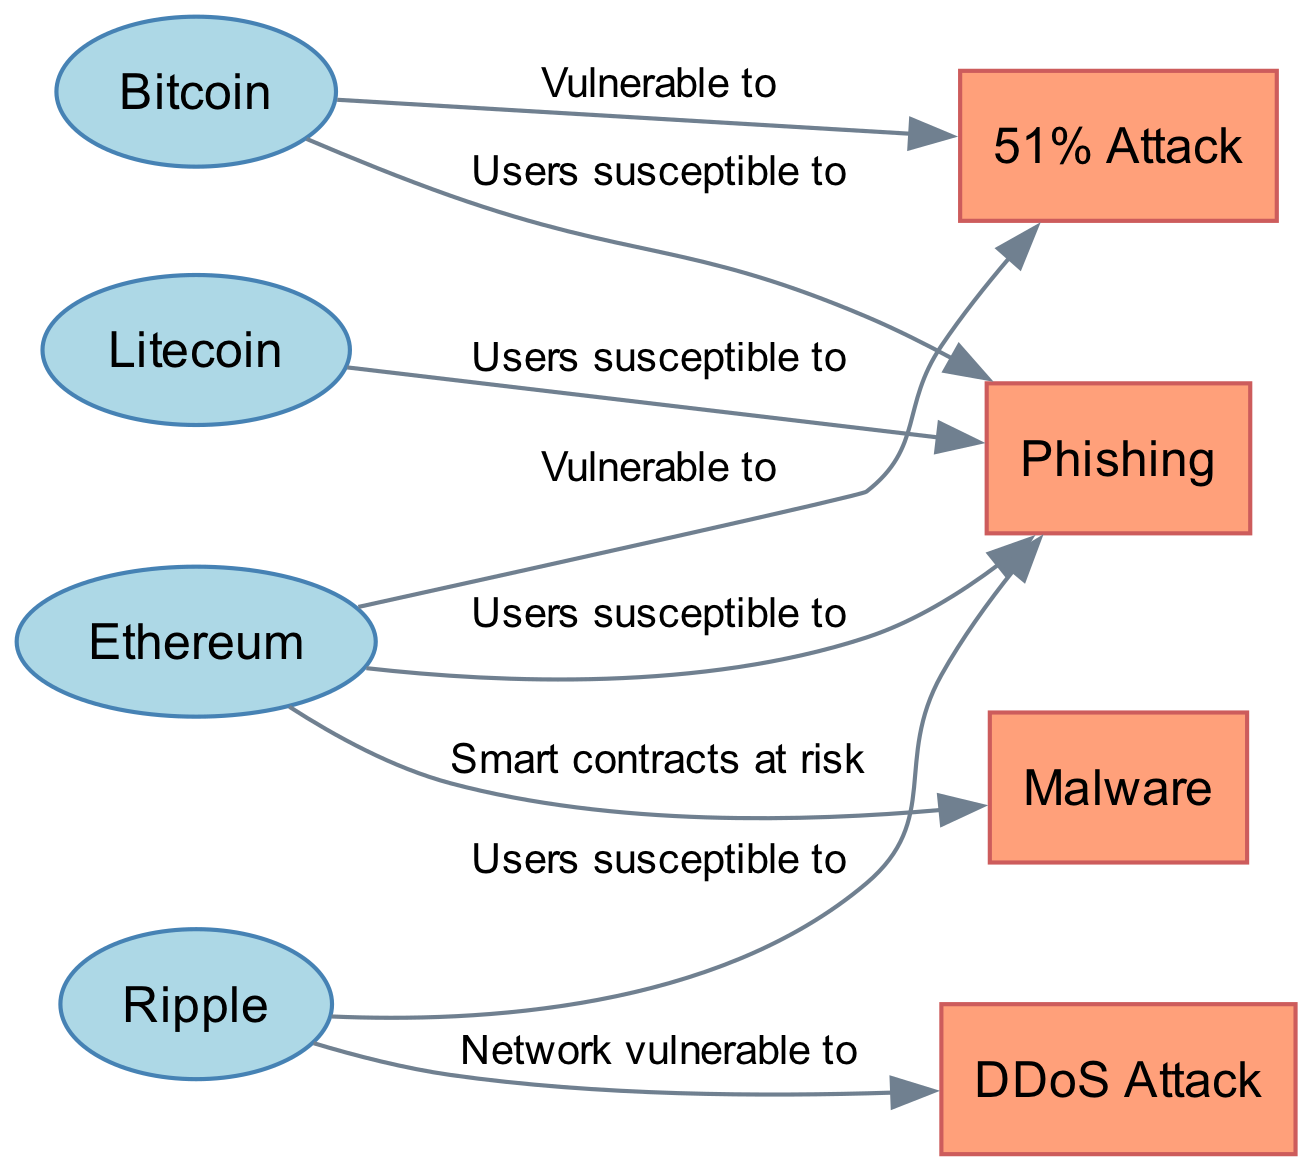What are the types of nodes in this diagram? The diagram consists of two main types of nodes: cryptocurrencies (e.g., Bitcoin, Ethereum) and cyber attacks (e.g., 51% Attack, Phishing). This distinction can be made by examining the node properties listed in the data – some are labeled as "cryptocurrency" and others as "cyber_attack".
Answer: cryptocurrency, cyber attack How many cryptocurrencies are represented in the diagram? Counting the nodes that are labeled as cryptocurrencies, we find four: Bitcoin, Ethereum, Ripple, and Litecoin. This can be easily confirmed by listing or visually identifying the nodes in the diagram.
Answer: 4 Which cryptocurrency is vulnerable to a 51% attack? Based on the edges connecting the nodes, both Bitcoin and Ethereum have connections labeled "Vulnerable to" that point to 51% Attack, confirming their vulnerability. This is shown in the edges section where the two cryptocurrencies are linked to the attack type.
Answer: Bitcoin, Ethereum How many attack types are represented in the diagram? There are four attack types indicated in the node list: 51% Attack, Phishing, Malware, and DDoS Attack. One can determine this by reviewing the nodes specifically classified as "cyber_attack" in the data provided.
Answer: 4 Which cryptocurrency users are susceptible to phishing? Users of Bitcoin, Ethereum, Ripple, and Litecoin are all indicated as susceptible to phishing attacks, as shown by the edges connected to the Phishing node. Each edge labeled "Users susceptible to" directly links the cryptocurrencies to phishing.
Answer: Bitcoin, Ethereum, Ripple, Litecoin Which cryptocurrency is at risk from malware? Ethereum is the only cryptocurrency listed as facing risk from malware, as indicated by the edge labeled "Smart contracts at risk" which connects Ethereum to the Malware node. This can be directly derived from the edges present in the diagram.
Answer: Ethereum Which cryptocurrency network is vulnerable to DDoS attacks? The Ripple network is indicated to be vulnerable to DDoS attacks, as shown by the edge connecting XRP to the DDoS Attack node, explicitly labeled "Network vulnerable to". This can be confirmed by examining the edges in the diagram.
Answer: Ripple How many edges connect to the Phishing node? There are four edges connected to the Phishing node, indicating its relationship with Bitcoin, Ethereum, Ripple, and Litecoin. This can be easily counted by looking at how many times Phishing appears as a target in the edges section.
Answer: 4 